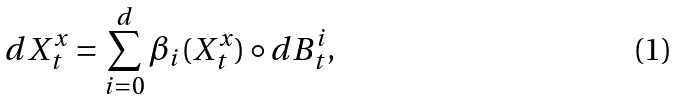Convert formula to latex. <formula><loc_0><loc_0><loc_500><loc_500>d X ^ { x } _ { t } = \sum _ { i = 0 } ^ { d } \beta _ { i } ( X ^ { x } _ { t } ) \circ d B ^ { i } _ { t } ,</formula> 